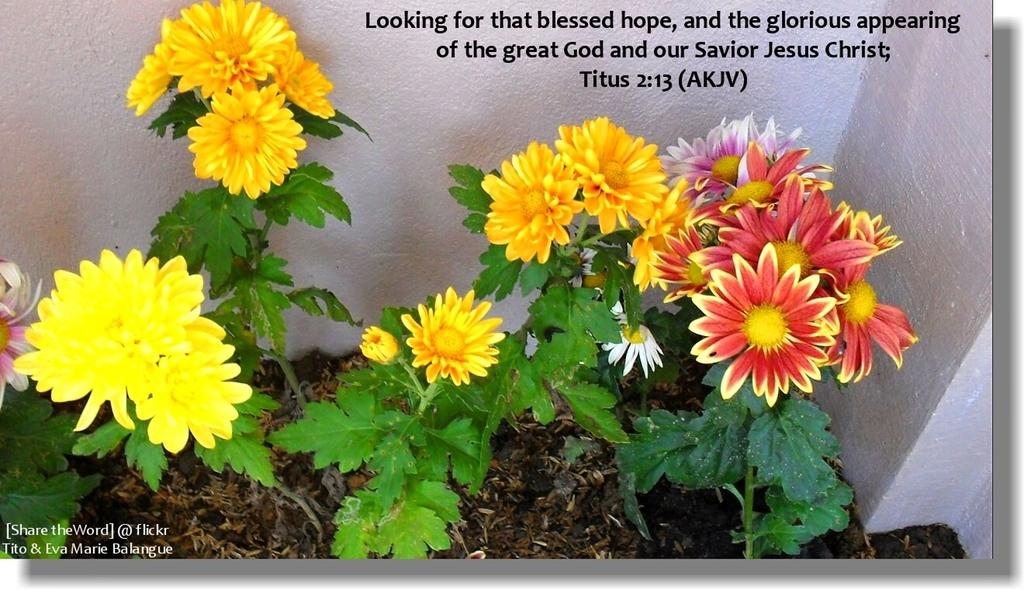What type of living organisms can be seen in the image? Plants can be seen in the image. What specific features do the plants have? The plants have flowers. What colors can be observed in the flowers? The flowers are of various colors, including yellow, orange, white, pink, and red. What else is visible in the image besides the plants? There is a wall and words visible in the image. What news story is being discussed in the image? There is no news story present in the image; it features plants with flowers and a wall with words. What type of dish is being prepared in the image? There is no cooking or preparation of food visible in the image. 